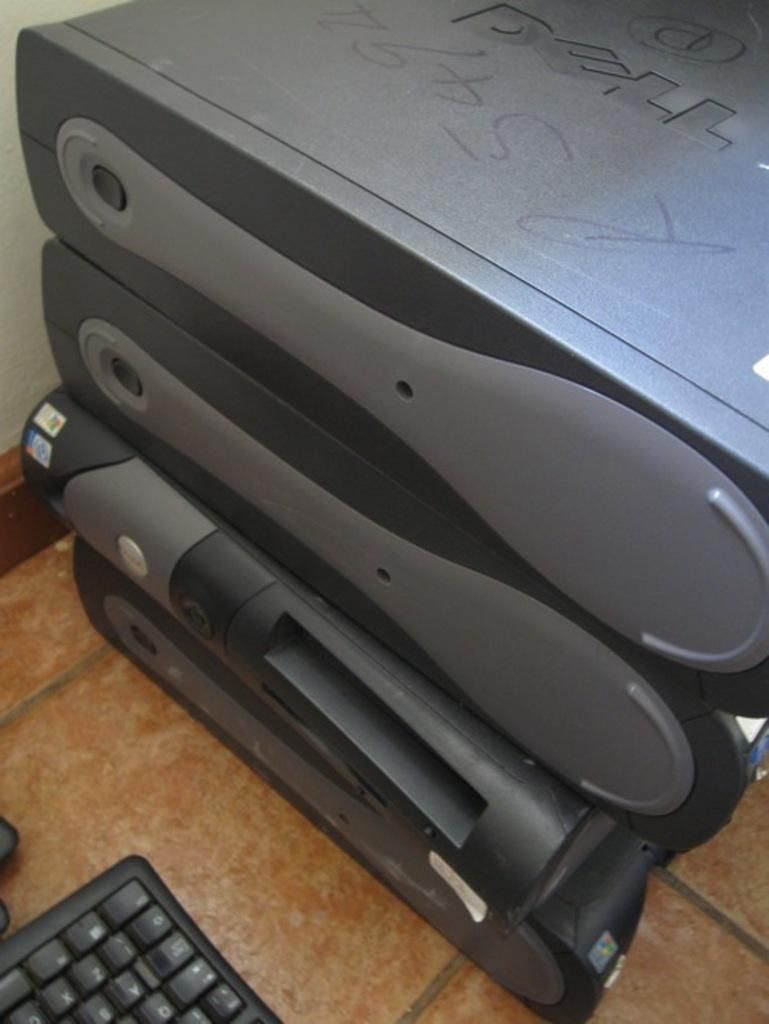<image>
Present a compact description of the photo's key features. Several Dell brand computers are stacked up on top of each other. 